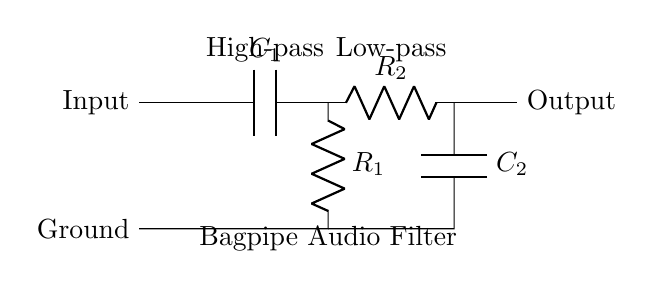What type of filter does C1 represent? C1 is part of a high-pass filter, which allows signals above a certain frequency to pass while attenuating lower frequencies.
Answer: High-pass What is the purpose of R2 in this circuit? R2 is part of the low-pass filter, which allows signals below a certain frequency to pass while blocking higher frequencies.
Answer: Allow low frequencies How many capacitors are in the circuit? The circuit contains two capacitors, one labeled C1 and the other C2.
Answer: Two What is the output connection in the circuit? The output connection is made on the right side of the circuit, which allows the filtered audio signal to be sent out.
Answer: Output What does the label "Bagpipe Audio Filter" indicate in the circuit? The label indicates that this circuit is specifically designed to filter audio signals from bagpipes, enhancing the recording quality.
Answer: Purpose of circuit What happens to frequencies below the cutoff frequency set by R1 and C1? Frequencies below the cutoff frequency are attenuated, meaning they are reduced in amplitude, effectively filtering them out of the output.
Answer: Attenuated What is the function of the ground connection in this circuit? The ground connection serves as a reference point in the circuit for the return path of the current, stabilizing the operation of the filters.
Answer: Reference point 